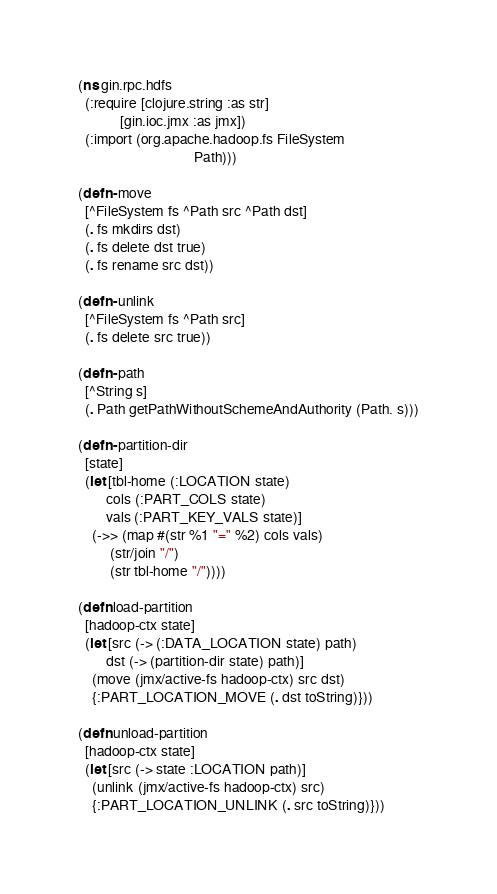Convert code to text. <code><loc_0><loc_0><loc_500><loc_500><_Clojure_>(ns gin.rpc.hdfs
  (:require [clojure.string :as str]
            [gin.ioc.jmx :as jmx])
  (:import (org.apache.hadoop.fs FileSystem
                                 Path)))

(defn- move
  [^FileSystem fs ^Path src ^Path dst]
  (. fs mkdirs dst)
  (. fs delete dst true)
  (. fs rename src dst))

(defn- unlink
  [^FileSystem fs ^Path src]
  (. fs delete src true))

(defn- path
  [^String s]
  (. Path getPathWithoutSchemeAndAuthority (Path. s)))

(defn- partition-dir
  [state]
  (let [tbl-home (:LOCATION state)
        cols (:PART_COLS state)
        vals (:PART_KEY_VALS state)]
    (->> (map #(str %1 "=" %2) cols vals)
         (str/join "/")
         (str tbl-home "/"))))

(defn load-partition
  [hadoop-ctx state]
  (let [src (-> (:DATA_LOCATION state) path)
        dst (-> (partition-dir state) path)]
    (move (jmx/active-fs hadoop-ctx) src dst)
    {:PART_LOCATION_MOVE (. dst toString)}))

(defn unload-partition
  [hadoop-ctx state]
  (let [src (-> state :LOCATION path)]
    (unlink (jmx/active-fs hadoop-ctx) src)
    {:PART_LOCATION_UNLINK (. src toString)}))
</code> 